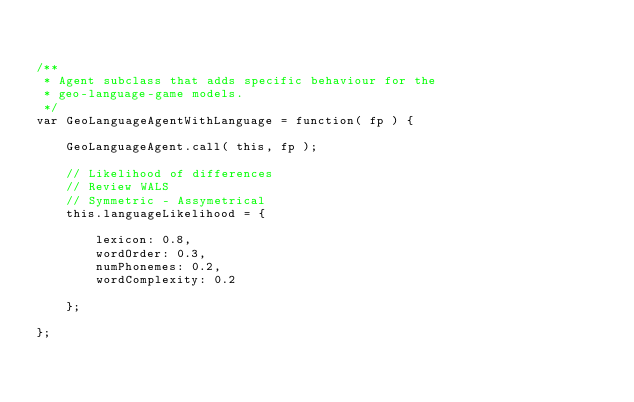<code> <loc_0><loc_0><loc_500><loc_500><_JavaScript_>

/**
 * Agent subclass that adds specific behaviour for the
 * geo-language-game models.
 */
var GeoLanguageAgentWithLanguage = function( fp ) {

    GeoLanguageAgent.call( this, fp );

    // Likelihood of differences
    // Review WALS
    // Symmetric - Assymetrical
    this.languageLikelihood = {

        lexicon: 0.8,
        wordOrder: 0.3,
        numPhonemes: 0.2,
        wordComplexity: 0.2

    };

};



</code> 